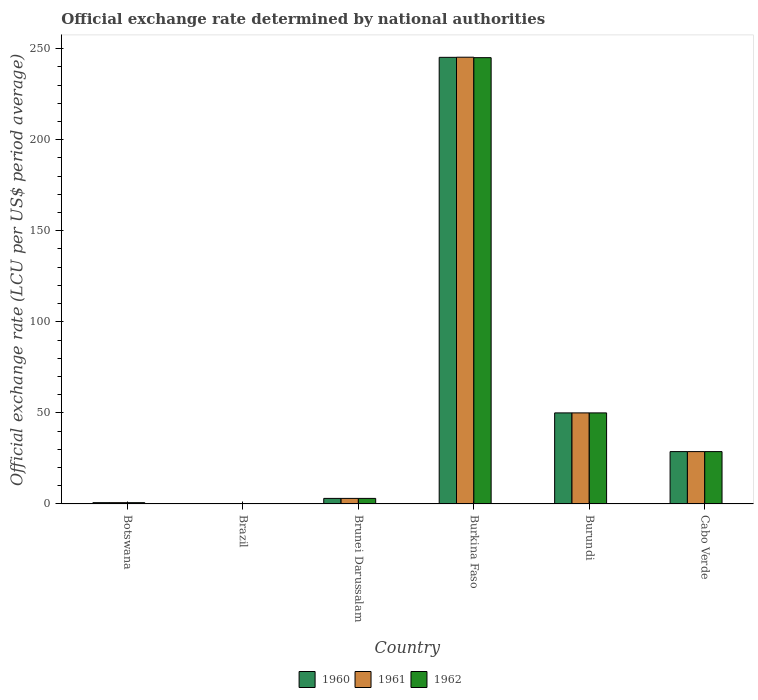Are the number of bars per tick equal to the number of legend labels?
Keep it short and to the point. Yes. How many bars are there on the 3rd tick from the left?
Provide a short and direct response. 3. How many bars are there on the 1st tick from the right?
Make the answer very short. 3. What is the label of the 3rd group of bars from the left?
Your answer should be compact. Brunei Darussalam. In how many cases, is the number of bars for a given country not equal to the number of legend labels?
Offer a very short reply. 0. What is the official exchange rate in 1962 in Cabo Verde?
Offer a terse response. 28.75. Across all countries, what is the maximum official exchange rate in 1961?
Your answer should be compact. 245.26. Across all countries, what is the minimum official exchange rate in 1960?
Give a very brief answer. 8.099705334969949e-14. In which country was the official exchange rate in 1961 maximum?
Offer a terse response. Burkina Faso. What is the total official exchange rate in 1960 in the graph?
Keep it short and to the point. 327.72. What is the difference between the official exchange rate in 1962 in Burundi and that in Cabo Verde?
Your response must be concise. 21.25. What is the difference between the official exchange rate in 1960 in Cabo Verde and the official exchange rate in 1961 in Brunei Darussalam?
Offer a terse response. 25.69. What is the average official exchange rate in 1962 per country?
Provide a short and direct response. 54.59. What is the difference between the official exchange rate of/in 1961 and official exchange rate of/in 1960 in Burkina Faso?
Provide a succinct answer. 0.07. In how many countries, is the official exchange rate in 1961 greater than 110 LCU?
Offer a terse response. 1. What is the ratio of the official exchange rate in 1960 in Botswana to that in Brunei Darussalam?
Provide a short and direct response. 0.23. Is the difference between the official exchange rate in 1961 in Botswana and Cabo Verde greater than the difference between the official exchange rate in 1960 in Botswana and Cabo Verde?
Your response must be concise. Yes. What is the difference between the highest and the second highest official exchange rate in 1960?
Keep it short and to the point. 21.25. What is the difference between the highest and the lowest official exchange rate in 1961?
Provide a short and direct response. 245.26. Is it the case that in every country, the sum of the official exchange rate in 1961 and official exchange rate in 1962 is greater than the official exchange rate in 1960?
Keep it short and to the point. Yes. How many bars are there?
Your answer should be compact. 18. What is the difference between two consecutive major ticks on the Y-axis?
Make the answer very short. 50. How are the legend labels stacked?
Your answer should be very brief. Horizontal. What is the title of the graph?
Your response must be concise. Official exchange rate determined by national authorities. Does "1973" appear as one of the legend labels in the graph?
Offer a very short reply. No. What is the label or title of the Y-axis?
Offer a very short reply. Official exchange rate (LCU per US$ period average). What is the Official exchange rate (LCU per US$ period average) in 1960 in Botswana?
Provide a succinct answer. 0.71. What is the Official exchange rate (LCU per US$ period average) of 1961 in Botswana?
Make the answer very short. 0.71. What is the Official exchange rate (LCU per US$ period average) in 1962 in Botswana?
Offer a terse response. 0.71. What is the Official exchange rate (LCU per US$ period average) in 1960 in Brazil?
Offer a very short reply. 8.099705334969949e-14. What is the Official exchange rate (LCU per US$ period average) in 1961 in Brazil?
Your answer should be very brief. 1.16843478826882e-13. What is the Official exchange rate (LCU per US$ period average) in 1962 in Brazil?
Your answer should be compact. 1.67764155487091e-13. What is the Official exchange rate (LCU per US$ period average) of 1960 in Brunei Darussalam?
Give a very brief answer. 3.06. What is the Official exchange rate (LCU per US$ period average) of 1961 in Brunei Darussalam?
Provide a succinct answer. 3.06. What is the Official exchange rate (LCU per US$ period average) of 1962 in Brunei Darussalam?
Your answer should be very brief. 3.06. What is the Official exchange rate (LCU per US$ period average) in 1960 in Burkina Faso?
Give a very brief answer. 245.2. What is the Official exchange rate (LCU per US$ period average) of 1961 in Burkina Faso?
Make the answer very short. 245.26. What is the Official exchange rate (LCU per US$ period average) in 1962 in Burkina Faso?
Keep it short and to the point. 245.01. What is the Official exchange rate (LCU per US$ period average) in 1960 in Burundi?
Ensure brevity in your answer.  50. What is the Official exchange rate (LCU per US$ period average) in 1961 in Burundi?
Provide a succinct answer. 50. What is the Official exchange rate (LCU per US$ period average) in 1962 in Burundi?
Your answer should be compact. 50. What is the Official exchange rate (LCU per US$ period average) in 1960 in Cabo Verde?
Your response must be concise. 28.75. What is the Official exchange rate (LCU per US$ period average) in 1961 in Cabo Verde?
Offer a terse response. 28.75. What is the Official exchange rate (LCU per US$ period average) in 1962 in Cabo Verde?
Make the answer very short. 28.75. Across all countries, what is the maximum Official exchange rate (LCU per US$ period average) in 1960?
Ensure brevity in your answer.  245.2. Across all countries, what is the maximum Official exchange rate (LCU per US$ period average) in 1961?
Offer a very short reply. 245.26. Across all countries, what is the maximum Official exchange rate (LCU per US$ period average) of 1962?
Your answer should be compact. 245.01. Across all countries, what is the minimum Official exchange rate (LCU per US$ period average) of 1960?
Your answer should be compact. 8.099705334969949e-14. Across all countries, what is the minimum Official exchange rate (LCU per US$ period average) in 1961?
Your answer should be compact. 1.16843478826882e-13. Across all countries, what is the minimum Official exchange rate (LCU per US$ period average) in 1962?
Your answer should be compact. 1.67764155487091e-13. What is the total Official exchange rate (LCU per US$ period average) of 1960 in the graph?
Provide a succinct answer. 327.72. What is the total Official exchange rate (LCU per US$ period average) in 1961 in the graph?
Your response must be concise. 327.79. What is the total Official exchange rate (LCU per US$ period average) in 1962 in the graph?
Make the answer very short. 327.54. What is the difference between the Official exchange rate (LCU per US$ period average) of 1960 in Botswana and that in Brazil?
Keep it short and to the point. 0.71. What is the difference between the Official exchange rate (LCU per US$ period average) of 1961 in Botswana and that in Brazil?
Ensure brevity in your answer.  0.71. What is the difference between the Official exchange rate (LCU per US$ period average) in 1962 in Botswana and that in Brazil?
Give a very brief answer. 0.71. What is the difference between the Official exchange rate (LCU per US$ period average) in 1960 in Botswana and that in Brunei Darussalam?
Keep it short and to the point. -2.35. What is the difference between the Official exchange rate (LCU per US$ period average) of 1961 in Botswana and that in Brunei Darussalam?
Provide a succinct answer. -2.35. What is the difference between the Official exchange rate (LCU per US$ period average) in 1962 in Botswana and that in Brunei Darussalam?
Offer a very short reply. -2.35. What is the difference between the Official exchange rate (LCU per US$ period average) in 1960 in Botswana and that in Burkina Faso?
Offer a terse response. -244.48. What is the difference between the Official exchange rate (LCU per US$ period average) in 1961 in Botswana and that in Burkina Faso?
Your response must be concise. -244.55. What is the difference between the Official exchange rate (LCU per US$ period average) of 1962 in Botswana and that in Burkina Faso?
Ensure brevity in your answer.  -244.3. What is the difference between the Official exchange rate (LCU per US$ period average) of 1960 in Botswana and that in Burundi?
Your response must be concise. -49.29. What is the difference between the Official exchange rate (LCU per US$ period average) in 1961 in Botswana and that in Burundi?
Provide a short and direct response. -49.29. What is the difference between the Official exchange rate (LCU per US$ period average) in 1962 in Botswana and that in Burundi?
Provide a short and direct response. -49.29. What is the difference between the Official exchange rate (LCU per US$ period average) of 1960 in Botswana and that in Cabo Verde?
Make the answer very short. -28.04. What is the difference between the Official exchange rate (LCU per US$ period average) in 1961 in Botswana and that in Cabo Verde?
Ensure brevity in your answer.  -28.04. What is the difference between the Official exchange rate (LCU per US$ period average) of 1962 in Botswana and that in Cabo Verde?
Give a very brief answer. -28.04. What is the difference between the Official exchange rate (LCU per US$ period average) in 1960 in Brazil and that in Brunei Darussalam?
Give a very brief answer. -3.06. What is the difference between the Official exchange rate (LCU per US$ period average) of 1961 in Brazil and that in Brunei Darussalam?
Your answer should be very brief. -3.06. What is the difference between the Official exchange rate (LCU per US$ period average) of 1962 in Brazil and that in Brunei Darussalam?
Your response must be concise. -3.06. What is the difference between the Official exchange rate (LCU per US$ period average) in 1960 in Brazil and that in Burkina Faso?
Your response must be concise. -245.2. What is the difference between the Official exchange rate (LCU per US$ period average) in 1961 in Brazil and that in Burkina Faso?
Offer a terse response. -245.26. What is the difference between the Official exchange rate (LCU per US$ period average) of 1962 in Brazil and that in Burkina Faso?
Your response must be concise. -245.01. What is the difference between the Official exchange rate (LCU per US$ period average) of 1961 in Brazil and that in Burundi?
Ensure brevity in your answer.  -50. What is the difference between the Official exchange rate (LCU per US$ period average) of 1960 in Brazil and that in Cabo Verde?
Your answer should be compact. -28.75. What is the difference between the Official exchange rate (LCU per US$ period average) in 1961 in Brazil and that in Cabo Verde?
Keep it short and to the point. -28.75. What is the difference between the Official exchange rate (LCU per US$ period average) in 1962 in Brazil and that in Cabo Verde?
Keep it short and to the point. -28.75. What is the difference between the Official exchange rate (LCU per US$ period average) of 1960 in Brunei Darussalam and that in Burkina Faso?
Give a very brief answer. -242.13. What is the difference between the Official exchange rate (LCU per US$ period average) of 1961 in Brunei Darussalam and that in Burkina Faso?
Provide a short and direct response. -242.2. What is the difference between the Official exchange rate (LCU per US$ period average) of 1962 in Brunei Darussalam and that in Burkina Faso?
Your answer should be very brief. -241.95. What is the difference between the Official exchange rate (LCU per US$ period average) of 1960 in Brunei Darussalam and that in Burundi?
Your response must be concise. -46.94. What is the difference between the Official exchange rate (LCU per US$ period average) of 1961 in Brunei Darussalam and that in Burundi?
Make the answer very short. -46.94. What is the difference between the Official exchange rate (LCU per US$ period average) in 1962 in Brunei Darussalam and that in Burundi?
Your answer should be compact. -46.94. What is the difference between the Official exchange rate (LCU per US$ period average) of 1960 in Brunei Darussalam and that in Cabo Verde?
Keep it short and to the point. -25.69. What is the difference between the Official exchange rate (LCU per US$ period average) in 1961 in Brunei Darussalam and that in Cabo Verde?
Give a very brief answer. -25.69. What is the difference between the Official exchange rate (LCU per US$ period average) in 1962 in Brunei Darussalam and that in Cabo Verde?
Give a very brief answer. -25.69. What is the difference between the Official exchange rate (LCU per US$ period average) of 1960 in Burkina Faso and that in Burundi?
Provide a succinct answer. 195.2. What is the difference between the Official exchange rate (LCU per US$ period average) in 1961 in Burkina Faso and that in Burundi?
Keep it short and to the point. 195.26. What is the difference between the Official exchange rate (LCU per US$ period average) in 1962 in Burkina Faso and that in Burundi?
Give a very brief answer. 195.01. What is the difference between the Official exchange rate (LCU per US$ period average) of 1960 in Burkina Faso and that in Cabo Verde?
Give a very brief answer. 216.45. What is the difference between the Official exchange rate (LCU per US$ period average) in 1961 in Burkina Faso and that in Cabo Verde?
Provide a succinct answer. 216.51. What is the difference between the Official exchange rate (LCU per US$ period average) of 1962 in Burkina Faso and that in Cabo Verde?
Provide a succinct answer. 216.26. What is the difference between the Official exchange rate (LCU per US$ period average) in 1960 in Burundi and that in Cabo Verde?
Offer a very short reply. 21.25. What is the difference between the Official exchange rate (LCU per US$ period average) of 1961 in Burundi and that in Cabo Verde?
Give a very brief answer. 21.25. What is the difference between the Official exchange rate (LCU per US$ period average) in 1962 in Burundi and that in Cabo Verde?
Your response must be concise. 21.25. What is the difference between the Official exchange rate (LCU per US$ period average) in 1960 in Botswana and the Official exchange rate (LCU per US$ period average) in 1961 in Brazil?
Your answer should be compact. 0.71. What is the difference between the Official exchange rate (LCU per US$ period average) in 1960 in Botswana and the Official exchange rate (LCU per US$ period average) in 1962 in Brazil?
Offer a terse response. 0.71. What is the difference between the Official exchange rate (LCU per US$ period average) in 1961 in Botswana and the Official exchange rate (LCU per US$ period average) in 1962 in Brazil?
Your answer should be very brief. 0.71. What is the difference between the Official exchange rate (LCU per US$ period average) in 1960 in Botswana and the Official exchange rate (LCU per US$ period average) in 1961 in Brunei Darussalam?
Your answer should be compact. -2.35. What is the difference between the Official exchange rate (LCU per US$ period average) of 1960 in Botswana and the Official exchange rate (LCU per US$ period average) of 1962 in Brunei Darussalam?
Your answer should be compact. -2.35. What is the difference between the Official exchange rate (LCU per US$ period average) of 1961 in Botswana and the Official exchange rate (LCU per US$ period average) of 1962 in Brunei Darussalam?
Make the answer very short. -2.35. What is the difference between the Official exchange rate (LCU per US$ period average) of 1960 in Botswana and the Official exchange rate (LCU per US$ period average) of 1961 in Burkina Faso?
Ensure brevity in your answer.  -244.55. What is the difference between the Official exchange rate (LCU per US$ period average) in 1960 in Botswana and the Official exchange rate (LCU per US$ period average) in 1962 in Burkina Faso?
Offer a terse response. -244.3. What is the difference between the Official exchange rate (LCU per US$ period average) in 1961 in Botswana and the Official exchange rate (LCU per US$ period average) in 1962 in Burkina Faso?
Your answer should be compact. -244.3. What is the difference between the Official exchange rate (LCU per US$ period average) of 1960 in Botswana and the Official exchange rate (LCU per US$ period average) of 1961 in Burundi?
Your answer should be very brief. -49.29. What is the difference between the Official exchange rate (LCU per US$ period average) in 1960 in Botswana and the Official exchange rate (LCU per US$ period average) in 1962 in Burundi?
Keep it short and to the point. -49.29. What is the difference between the Official exchange rate (LCU per US$ period average) in 1961 in Botswana and the Official exchange rate (LCU per US$ period average) in 1962 in Burundi?
Your answer should be very brief. -49.29. What is the difference between the Official exchange rate (LCU per US$ period average) of 1960 in Botswana and the Official exchange rate (LCU per US$ period average) of 1961 in Cabo Verde?
Your answer should be compact. -28.04. What is the difference between the Official exchange rate (LCU per US$ period average) in 1960 in Botswana and the Official exchange rate (LCU per US$ period average) in 1962 in Cabo Verde?
Your answer should be very brief. -28.04. What is the difference between the Official exchange rate (LCU per US$ period average) of 1961 in Botswana and the Official exchange rate (LCU per US$ period average) of 1962 in Cabo Verde?
Keep it short and to the point. -28.04. What is the difference between the Official exchange rate (LCU per US$ period average) in 1960 in Brazil and the Official exchange rate (LCU per US$ period average) in 1961 in Brunei Darussalam?
Your answer should be very brief. -3.06. What is the difference between the Official exchange rate (LCU per US$ period average) of 1960 in Brazil and the Official exchange rate (LCU per US$ period average) of 1962 in Brunei Darussalam?
Your answer should be very brief. -3.06. What is the difference between the Official exchange rate (LCU per US$ period average) in 1961 in Brazil and the Official exchange rate (LCU per US$ period average) in 1962 in Brunei Darussalam?
Keep it short and to the point. -3.06. What is the difference between the Official exchange rate (LCU per US$ period average) in 1960 in Brazil and the Official exchange rate (LCU per US$ period average) in 1961 in Burkina Faso?
Your answer should be very brief. -245.26. What is the difference between the Official exchange rate (LCU per US$ period average) in 1960 in Brazil and the Official exchange rate (LCU per US$ period average) in 1962 in Burkina Faso?
Make the answer very short. -245.01. What is the difference between the Official exchange rate (LCU per US$ period average) of 1961 in Brazil and the Official exchange rate (LCU per US$ period average) of 1962 in Burkina Faso?
Keep it short and to the point. -245.01. What is the difference between the Official exchange rate (LCU per US$ period average) of 1961 in Brazil and the Official exchange rate (LCU per US$ period average) of 1962 in Burundi?
Offer a very short reply. -50. What is the difference between the Official exchange rate (LCU per US$ period average) of 1960 in Brazil and the Official exchange rate (LCU per US$ period average) of 1961 in Cabo Verde?
Give a very brief answer. -28.75. What is the difference between the Official exchange rate (LCU per US$ period average) of 1960 in Brazil and the Official exchange rate (LCU per US$ period average) of 1962 in Cabo Verde?
Provide a short and direct response. -28.75. What is the difference between the Official exchange rate (LCU per US$ period average) in 1961 in Brazil and the Official exchange rate (LCU per US$ period average) in 1962 in Cabo Verde?
Provide a short and direct response. -28.75. What is the difference between the Official exchange rate (LCU per US$ period average) in 1960 in Brunei Darussalam and the Official exchange rate (LCU per US$ period average) in 1961 in Burkina Faso?
Make the answer very short. -242.2. What is the difference between the Official exchange rate (LCU per US$ period average) of 1960 in Brunei Darussalam and the Official exchange rate (LCU per US$ period average) of 1962 in Burkina Faso?
Keep it short and to the point. -241.95. What is the difference between the Official exchange rate (LCU per US$ period average) of 1961 in Brunei Darussalam and the Official exchange rate (LCU per US$ period average) of 1962 in Burkina Faso?
Keep it short and to the point. -241.95. What is the difference between the Official exchange rate (LCU per US$ period average) of 1960 in Brunei Darussalam and the Official exchange rate (LCU per US$ period average) of 1961 in Burundi?
Your answer should be compact. -46.94. What is the difference between the Official exchange rate (LCU per US$ period average) in 1960 in Brunei Darussalam and the Official exchange rate (LCU per US$ period average) in 1962 in Burundi?
Ensure brevity in your answer.  -46.94. What is the difference between the Official exchange rate (LCU per US$ period average) in 1961 in Brunei Darussalam and the Official exchange rate (LCU per US$ period average) in 1962 in Burundi?
Give a very brief answer. -46.94. What is the difference between the Official exchange rate (LCU per US$ period average) in 1960 in Brunei Darussalam and the Official exchange rate (LCU per US$ period average) in 1961 in Cabo Verde?
Ensure brevity in your answer.  -25.69. What is the difference between the Official exchange rate (LCU per US$ period average) of 1960 in Brunei Darussalam and the Official exchange rate (LCU per US$ period average) of 1962 in Cabo Verde?
Provide a short and direct response. -25.69. What is the difference between the Official exchange rate (LCU per US$ period average) of 1961 in Brunei Darussalam and the Official exchange rate (LCU per US$ period average) of 1962 in Cabo Verde?
Your answer should be very brief. -25.69. What is the difference between the Official exchange rate (LCU per US$ period average) of 1960 in Burkina Faso and the Official exchange rate (LCU per US$ period average) of 1961 in Burundi?
Provide a short and direct response. 195.2. What is the difference between the Official exchange rate (LCU per US$ period average) in 1960 in Burkina Faso and the Official exchange rate (LCU per US$ period average) in 1962 in Burundi?
Your answer should be very brief. 195.2. What is the difference between the Official exchange rate (LCU per US$ period average) in 1961 in Burkina Faso and the Official exchange rate (LCU per US$ period average) in 1962 in Burundi?
Ensure brevity in your answer.  195.26. What is the difference between the Official exchange rate (LCU per US$ period average) in 1960 in Burkina Faso and the Official exchange rate (LCU per US$ period average) in 1961 in Cabo Verde?
Offer a terse response. 216.45. What is the difference between the Official exchange rate (LCU per US$ period average) in 1960 in Burkina Faso and the Official exchange rate (LCU per US$ period average) in 1962 in Cabo Verde?
Offer a very short reply. 216.45. What is the difference between the Official exchange rate (LCU per US$ period average) of 1961 in Burkina Faso and the Official exchange rate (LCU per US$ period average) of 1962 in Cabo Verde?
Keep it short and to the point. 216.51. What is the difference between the Official exchange rate (LCU per US$ period average) in 1960 in Burundi and the Official exchange rate (LCU per US$ period average) in 1961 in Cabo Verde?
Your response must be concise. 21.25. What is the difference between the Official exchange rate (LCU per US$ period average) in 1960 in Burundi and the Official exchange rate (LCU per US$ period average) in 1962 in Cabo Verde?
Make the answer very short. 21.25. What is the difference between the Official exchange rate (LCU per US$ period average) of 1961 in Burundi and the Official exchange rate (LCU per US$ period average) of 1962 in Cabo Verde?
Your response must be concise. 21.25. What is the average Official exchange rate (LCU per US$ period average) in 1960 per country?
Provide a short and direct response. 54.62. What is the average Official exchange rate (LCU per US$ period average) of 1961 per country?
Your answer should be compact. 54.63. What is the average Official exchange rate (LCU per US$ period average) of 1962 per country?
Your answer should be very brief. 54.59. What is the difference between the Official exchange rate (LCU per US$ period average) in 1960 and Official exchange rate (LCU per US$ period average) in 1961 in Botswana?
Make the answer very short. -0. What is the difference between the Official exchange rate (LCU per US$ period average) in 1961 and Official exchange rate (LCU per US$ period average) in 1962 in Botswana?
Provide a short and direct response. 0. What is the difference between the Official exchange rate (LCU per US$ period average) of 1960 and Official exchange rate (LCU per US$ period average) of 1961 in Brazil?
Ensure brevity in your answer.  -0. What is the difference between the Official exchange rate (LCU per US$ period average) in 1960 and Official exchange rate (LCU per US$ period average) in 1962 in Brazil?
Make the answer very short. -0. What is the difference between the Official exchange rate (LCU per US$ period average) of 1960 and Official exchange rate (LCU per US$ period average) of 1962 in Brunei Darussalam?
Offer a terse response. 0. What is the difference between the Official exchange rate (LCU per US$ period average) of 1961 and Official exchange rate (LCU per US$ period average) of 1962 in Brunei Darussalam?
Provide a succinct answer. 0. What is the difference between the Official exchange rate (LCU per US$ period average) of 1960 and Official exchange rate (LCU per US$ period average) of 1961 in Burkina Faso?
Your response must be concise. -0.07. What is the difference between the Official exchange rate (LCU per US$ period average) of 1960 and Official exchange rate (LCU per US$ period average) of 1962 in Burkina Faso?
Your answer should be very brief. 0.18. What is the difference between the Official exchange rate (LCU per US$ period average) of 1961 and Official exchange rate (LCU per US$ period average) of 1962 in Burkina Faso?
Provide a succinct answer. 0.25. What is the difference between the Official exchange rate (LCU per US$ period average) of 1960 and Official exchange rate (LCU per US$ period average) of 1962 in Burundi?
Provide a succinct answer. 0. What is the difference between the Official exchange rate (LCU per US$ period average) of 1961 and Official exchange rate (LCU per US$ period average) of 1962 in Cabo Verde?
Make the answer very short. 0. What is the ratio of the Official exchange rate (LCU per US$ period average) of 1960 in Botswana to that in Brazil?
Offer a terse response. 8.81e+12. What is the ratio of the Official exchange rate (LCU per US$ period average) in 1961 in Botswana to that in Brazil?
Your answer should be very brief. 6.12e+12. What is the ratio of the Official exchange rate (LCU per US$ period average) of 1962 in Botswana to that in Brazil?
Provide a short and direct response. 4.25e+12. What is the ratio of the Official exchange rate (LCU per US$ period average) of 1960 in Botswana to that in Brunei Darussalam?
Offer a terse response. 0.23. What is the ratio of the Official exchange rate (LCU per US$ period average) in 1961 in Botswana to that in Brunei Darussalam?
Offer a terse response. 0.23. What is the ratio of the Official exchange rate (LCU per US$ period average) in 1962 in Botswana to that in Brunei Darussalam?
Your response must be concise. 0.23. What is the ratio of the Official exchange rate (LCU per US$ period average) of 1960 in Botswana to that in Burkina Faso?
Offer a terse response. 0. What is the ratio of the Official exchange rate (LCU per US$ period average) in 1961 in Botswana to that in Burkina Faso?
Provide a succinct answer. 0. What is the ratio of the Official exchange rate (LCU per US$ period average) in 1962 in Botswana to that in Burkina Faso?
Make the answer very short. 0. What is the ratio of the Official exchange rate (LCU per US$ period average) in 1960 in Botswana to that in Burundi?
Provide a short and direct response. 0.01. What is the ratio of the Official exchange rate (LCU per US$ period average) of 1961 in Botswana to that in Burundi?
Provide a succinct answer. 0.01. What is the ratio of the Official exchange rate (LCU per US$ period average) in 1962 in Botswana to that in Burundi?
Make the answer very short. 0.01. What is the ratio of the Official exchange rate (LCU per US$ period average) in 1960 in Botswana to that in Cabo Verde?
Provide a succinct answer. 0.02. What is the ratio of the Official exchange rate (LCU per US$ period average) in 1961 in Botswana to that in Cabo Verde?
Your response must be concise. 0.02. What is the ratio of the Official exchange rate (LCU per US$ period average) of 1962 in Botswana to that in Cabo Verde?
Your response must be concise. 0.02. What is the ratio of the Official exchange rate (LCU per US$ period average) in 1960 in Brazil to that in Brunei Darussalam?
Ensure brevity in your answer.  0. What is the ratio of the Official exchange rate (LCU per US$ period average) in 1961 in Brazil to that in Brunei Darussalam?
Provide a succinct answer. 0. What is the ratio of the Official exchange rate (LCU per US$ period average) in 1962 in Brazil to that in Burkina Faso?
Your answer should be very brief. 0. What is the ratio of the Official exchange rate (LCU per US$ period average) in 1960 in Brazil to that in Burundi?
Offer a terse response. 0. What is the ratio of the Official exchange rate (LCU per US$ period average) in 1961 in Brazil to that in Cabo Verde?
Offer a very short reply. 0. What is the ratio of the Official exchange rate (LCU per US$ period average) of 1960 in Brunei Darussalam to that in Burkina Faso?
Ensure brevity in your answer.  0.01. What is the ratio of the Official exchange rate (LCU per US$ period average) of 1961 in Brunei Darussalam to that in Burkina Faso?
Make the answer very short. 0.01. What is the ratio of the Official exchange rate (LCU per US$ period average) in 1962 in Brunei Darussalam to that in Burkina Faso?
Offer a very short reply. 0.01. What is the ratio of the Official exchange rate (LCU per US$ period average) in 1960 in Brunei Darussalam to that in Burundi?
Provide a short and direct response. 0.06. What is the ratio of the Official exchange rate (LCU per US$ period average) of 1961 in Brunei Darussalam to that in Burundi?
Give a very brief answer. 0.06. What is the ratio of the Official exchange rate (LCU per US$ period average) in 1962 in Brunei Darussalam to that in Burundi?
Make the answer very short. 0.06. What is the ratio of the Official exchange rate (LCU per US$ period average) of 1960 in Brunei Darussalam to that in Cabo Verde?
Offer a terse response. 0.11. What is the ratio of the Official exchange rate (LCU per US$ period average) of 1961 in Brunei Darussalam to that in Cabo Verde?
Your answer should be compact. 0.11. What is the ratio of the Official exchange rate (LCU per US$ period average) of 1962 in Brunei Darussalam to that in Cabo Verde?
Provide a short and direct response. 0.11. What is the ratio of the Official exchange rate (LCU per US$ period average) of 1960 in Burkina Faso to that in Burundi?
Ensure brevity in your answer.  4.9. What is the ratio of the Official exchange rate (LCU per US$ period average) of 1961 in Burkina Faso to that in Burundi?
Offer a terse response. 4.91. What is the ratio of the Official exchange rate (LCU per US$ period average) of 1962 in Burkina Faso to that in Burundi?
Your response must be concise. 4.9. What is the ratio of the Official exchange rate (LCU per US$ period average) in 1960 in Burkina Faso to that in Cabo Verde?
Provide a succinct answer. 8.53. What is the ratio of the Official exchange rate (LCU per US$ period average) in 1961 in Burkina Faso to that in Cabo Verde?
Provide a succinct answer. 8.53. What is the ratio of the Official exchange rate (LCU per US$ period average) in 1962 in Burkina Faso to that in Cabo Verde?
Provide a short and direct response. 8.52. What is the ratio of the Official exchange rate (LCU per US$ period average) in 1960 in Burundi to that in Cabo Verde?
Your answer should be very brief. 1.74. What is the ratio of the Official exchange rate (LCU per US$ period average) in 1961 in Burundi to that in Cabo Verde?
Keep it short and to the point. 1.74. What is the ratio of the Official exchange rate (LCU per US$ period average) in 1962 in Burundi to that in Cabo Verde?
Offer a terse response. 1.74. What is the difference between the highest and the second highest Official exchange rate (LCU per US$ period average) of 1960?
Your response must be concise. 195.2. What is the difference between the highest and the second highest Official exchange rate (LCU per US$ period average) of 1961?
Offer a very short reply. 195.26. What is the difference between the highest and the second highest Official exchange rate (LCU per US$ period average) of 1962?
Your response must be concise. 195.01. What is the difference between the highest and the lowest Official exchange rate (LCU per US$ period average) of 1960?
Ensure brevity in your answer.  245.2. What is the difference between the highest and the lowest Official exchange rate (LCU per US$ period average) in 1961?
Provide a succinct answer. 245.26. What is the difference between the highest and the lowest Official exchange rate (LCU per US$ period average) in 1962?
Offer a very short reply. 245.01. 